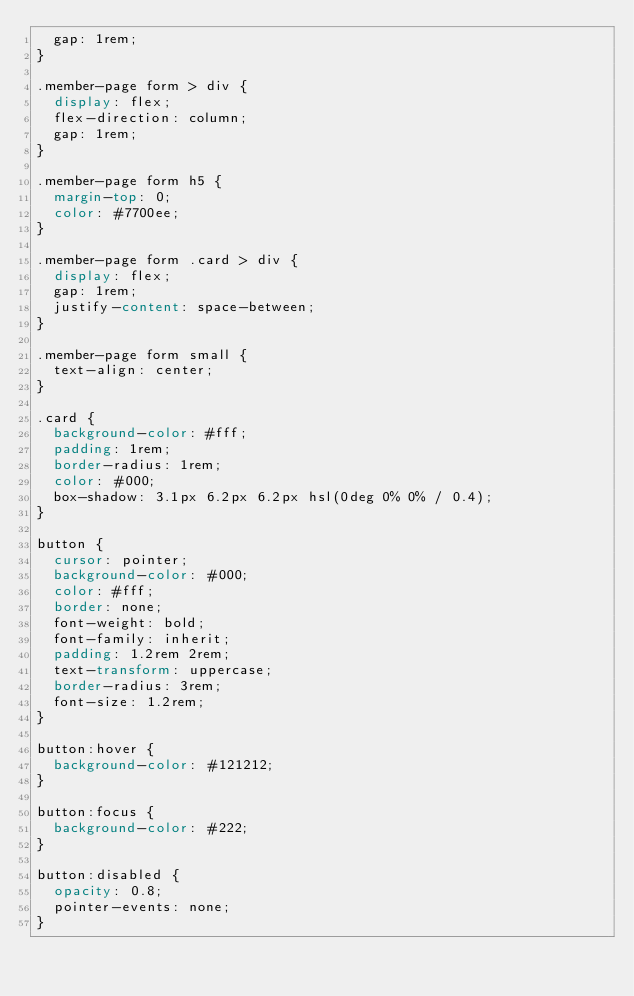Convert code to text. <code><loc_0><loc_0><loc_500><loc_500><_CSS_>  gap: 1rem;
}

.member-page form > div {
  display: flex;
  flex-direction: column;
  gap: 1rem;
}

.member-page form h5 {
  margin-top: 0;
  color: #7700ee;
}

.member-page form .card > div {
  display: flex;
  gap: 1rem;
  justify-content: space-between;
}

.member-page form small {
  text-align: center;
}

.card {
  background-color: #fff;
  padding: 1rem;
  border-radius: 1rem;
  color: #000;
  box-shadow: 3.1px 6.2px 6.2px hsl(0deg 0% 0% / 0.4);
}

button {
  cursor: pointer;
  background-color: #000;
  color: #fff;
  border: none;
  font-weight: bold;
  font-family: inherit;
  padding: 1.2rem 2rem;
  text-transform: uppercase;
  border-radius: 3rem;
  font-size: 1.2rem;
}

button:hover {
  background-color: #121212;
}

button:focus {
  background-color: #222;
}

button:disabled {
  opacity: 0.8;
  pointer-events: none;
}
</code> 